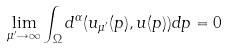Convert formula to latex. <formula><loc_0><loc_0><loc_500><loc_500>\lim _ { \mu ^ { \prime } \rightarrow \infty } \int _ { \Omega } d ^ { \alpha } ( u _ { \mu ^ { \prime } } ( p ) , u ( p ) ) d p = 0</formula> 